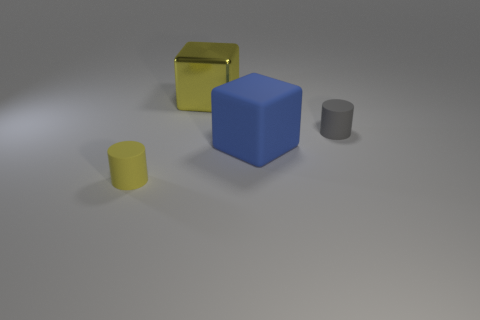There is a tiny thing that is the same color as the shiny block; what material is it?
Ensure brevity in your answer.  Rubber. What number of big blocks are the same color as the shiny thing?
Your answer should be compact. 0. Is the size of the blue rubber object the same as the rubber cylinder behind the small yellow rubber object?
Your answer should be compact. No. Does the metallic thing have the same size as the gray matte cylinder?
Offer a terse response. No. There is a object that is on the left side of the large blue rubber cube and behind the large blue rubber block; what material is it?
Your answer should be compact. Metal. What number of things are either big matte blocks or gray objects?
Provide a succinct answer. 2. Is the number of big yellow metal objects greater than the number of purple matte balls?
Your response must be concise. Yes. What is the size of the thing that is behind the matte cylinder right of the large yellow object?
Your answer should be very brief. Large. There is another tiny object that is the same shape as the small yellow thing; what color is it?
Keep it short and to the point. Gray. The shiny block has what size?
Your answer should be very brief. Large. 